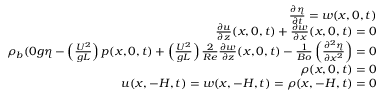Convert formula to latex. <formula><loc_0><loc_0><loc_500><loc_500>\begin{array} { r l r } & { \frac { \partial \eta } { \partial t } = w ( x , 0 , t ) } \\ & { \frac { \partial u } { \partial z } ( x , 0 , t ) + \frac { \partial w } { \partial x } ( x , 0 , t ) = 0 } \\ & { \rho _ { b } ( 0 g \eta - \left ( \frac { U ^ { 2 } } { g L } \right ) p ( x , 0 , t ) + \left ( \frac { U ^ { 2 } } { g L } \right ) \frac { 2 } { R e } \frac { \partial w } { \partial z } ( x , 0 , t ) - \frac { 1 } { B o } \left ( \frac { \partial ^ { 2 } \eta } { \partial x ^ { 2 } } \right ) = 0 } \\ & { \rho ( x , 0 , t ) = 0 } \\ & { u ( x , - H , t ) = w ( x , - H , t ) = \rho ( x , - H , t ) = 0 } \end{array}</formula> 